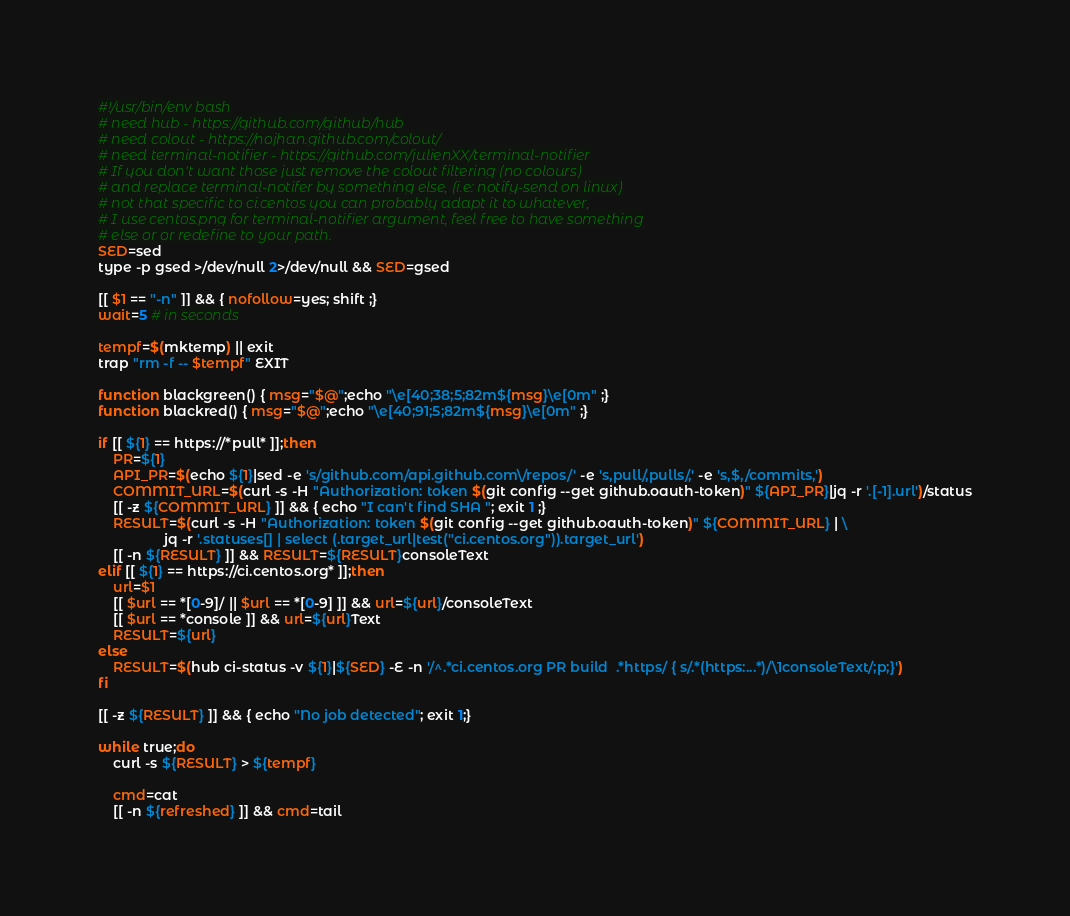Convert code to text. <code><loc_0><loc_0><loc_500><loc_500><_Bash_>#!/usr/bin/env bash
# need hub - https://github.com/github/hub
# need colout - https://nojhan.github.com/colout/
# need terminal-notifier - https://github.com/julienXX/terminal-notifier
# If you don't want those just remove the colout filtering (no colours)
# and replace terminal-notifer by something else, (i.e: notify-send on linux)
# not that specific to ci.centos you can probably adapt it to whatever,
# I use centos.png for terminal-notifier argument, feel free to have something
# else or or redefine to your path.
SED=sed
type -p gsed >/dev/null 2>/dev/null && SED=gsed

[[ $1 == "-n" ]] && { nofollow=yes; shift ;}
wait=5 # in seconds

tempf=$(mktemp) || exit
trap "rm -f -- $tempf" EXIT

function blackgreen() { msg="$@";echo "\e[40;38;5;82m${msg}\e[0m" ;}
function blackred() { msg="$@";echo "\e[40;91;5;82m${msg}\e[0m" ;}

if [[ ${1} == https://*pull* ]];then
    PR=${1}
    API_PR=$(echo ${1}|sed -e 's/github.com/api.github.com\/repos/' -e 's,pull/,pulls/,' -e 's,$,/commits,')
    COMMIT_URL=$(curl -s -H "Authorization: token $(git config --get github.oauth-token)" ${API_PR}|jq -r '.[-1].url')/status
    [[ -z ${COMMIT_URL} ]] && { echo "I can't find SHA "; exit 1 ;}
    RESULT=$(curl -s -H "Authorization: token $(git config --get github.oauth-token)" ${COMMIT_URL} | \
                 jq -r '.statuses[] | select (.target_url|test("ci.centos.org")).target_url')
    [[ -n ${RESULT} ]] && RESULT=${RESULT}consoleText
elif [[ ${1} == https://ci.centos.org* ]];then
    url=$1
    [[ $url == *[0-9]/ || $url == *[0-9] ]] && url=${url}/consoleText
    [[ $url == *console ]] && url=${url}Text
    RESULT=${url}
else
    RESULT=$(hub ci-status -v ${1}|${SED} -E -n '/^.*ci.centos.org PR build  .*https/ { s/.*(https:...*)/\1consoleText/;p;}')
fi

[[ -z ${RESULT} ]] && { echo "No job detected"; exit 1;}

while true;do
    curl -s ${RESULT} > ${tempf}

    cmd=cat
    [[ -n ${refreshed} ]] && cmd=tail
</code> 